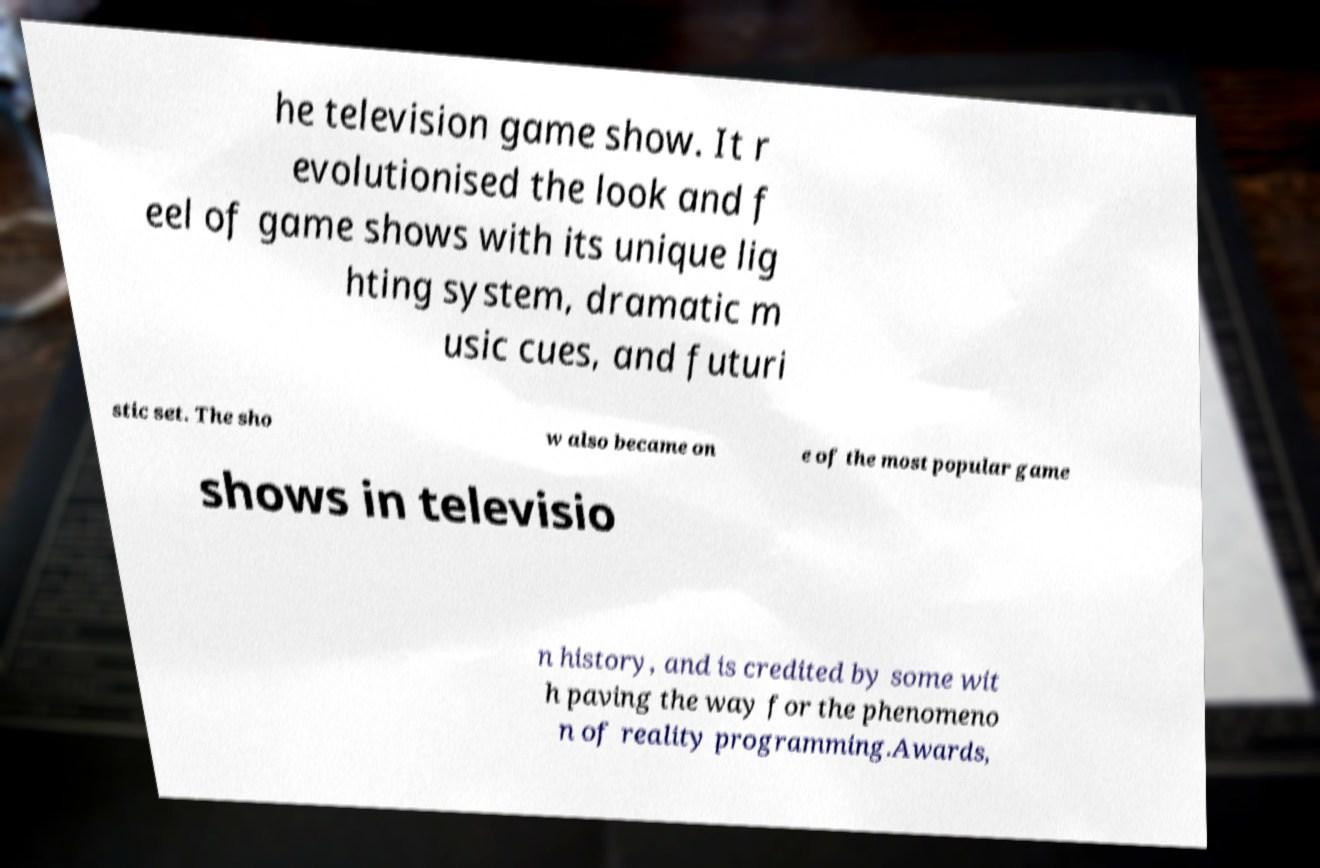What messages or text are displayed in this image? I need them in a readable, typed format. he television game show. It r evolutionised the look and f eel of game shows with its unique lig hting system, dramatic m usic cues, and futuri stic set. The sho w also became on e of the most popular game shows in televisio n history, and is credited by some wit h paving the way for the phenomeno n of reality programming.Awards, 